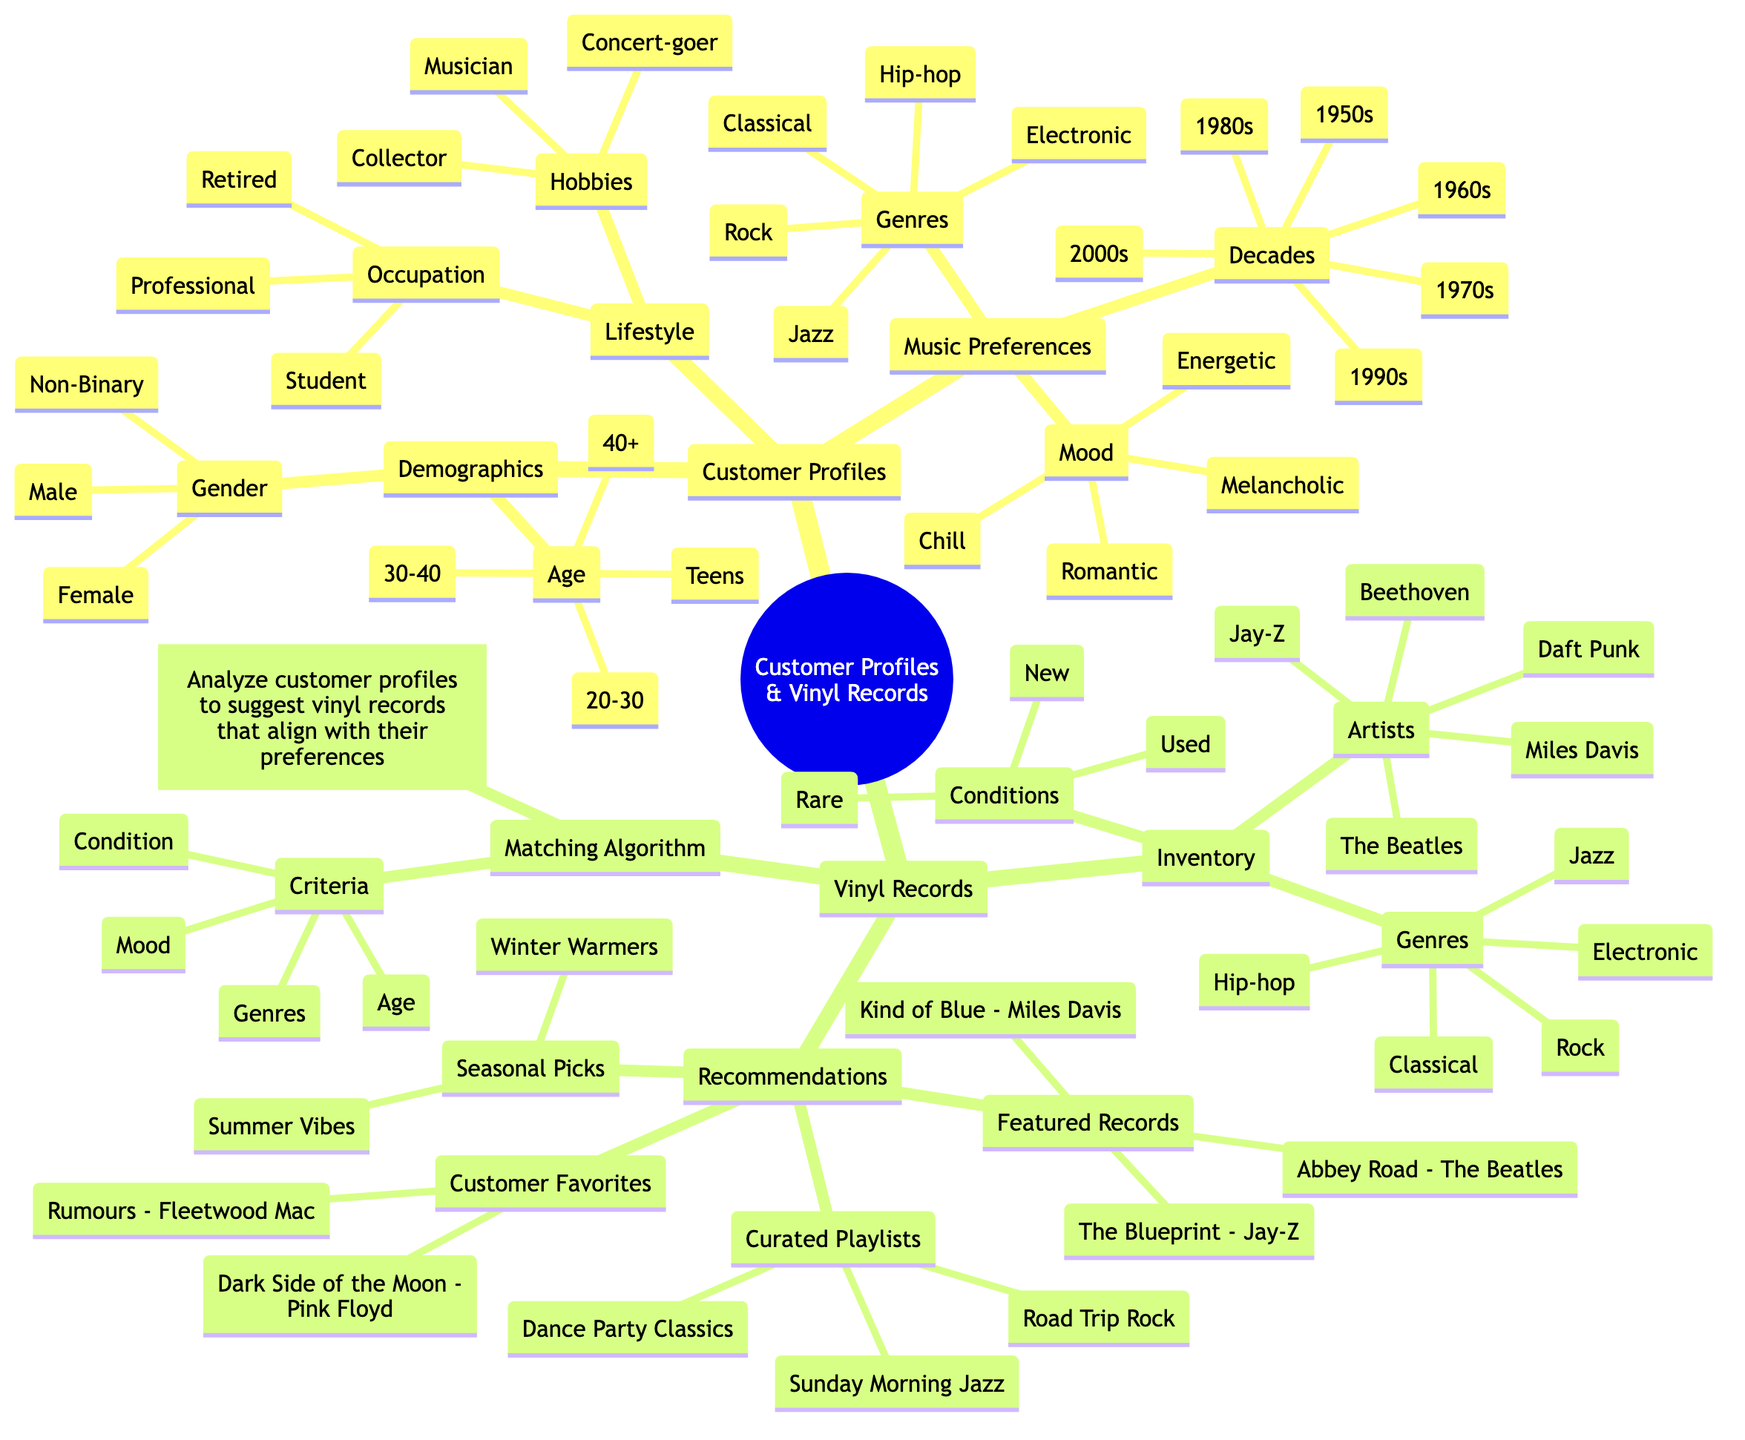What age groups are included in the customer profiles? The customer profiles section mentions age groups as part of the demographics. The specific age groups listed are "Teens," "20-30," "30-40," and "40+."
Answer: Teens, 20-30, 30-40, 40+ How many music genres are listed under music preferences? Looking at the Music Preferences section, there are two subcategories: Genres and each subcategory lists five specific genres: Rock, Jazz, Hip-hop, Classical, and Electronic. So, the total is five genres.
Answer: 5 What conditions are available for the vinyl records in the inventory? In the Vinyl Records Inventory section, the Conditions listed are "New," "Used," and "Rare." Therefore, there are three conditions.
Answer: New, Used, Rare Which playlist is suggested for a relaxing listening experience? By analyzing the Recommendations under Curated Playlists, "Sunday Morning Jazz" is associated with a chill ambiance that fits a relaxing mood.
Answer: Sunday Morning Jazz If a customer prefers Hip-hop music, what is a recommended featured record? In the Vinyl Records Recommendations section, "The Blueprint - Jay-Z" is explicitly categorized as a featured record under the Hip-hop genre, making it a suitable recommendation.
Answer: The Blueprint - Jay-Z How many customer favorite records are listed? In the Customer Favorites subsection, there are two records specifically mentioned. The records listed are "Dark Side of the Moon - Pink Floyd" and "Rumours - Fleetwood Mac." Thus, there are two customer favorites.
Answer: 2 What four criteria does the matching algorithm consider? The Matching Algorithm section lists the following criteria for matching: "Age," "Genres," "Mood," and "Condition." Therefore, those are the four criteria taken into account.
Answer: Age, Genres, Mood, Condition What hobbies do customers have in the lifestyle section? The Lifestyle segment of the Customer Profiles includes three hobbies: "Concert-goer," "Musician," and "Collector." Therefore, those hobbies are what the customers engage in.
Answer: Concert-goer, Musician, Collector Which decades are represented in the music preferences? The Music Preferences section includes the following decades: "1950s," "1960s," "1970s," "1980s," "1990s," and "2000s." In total, six decades are represented, indicating a broad range of musical eras.
Answer: 1950s, 1960s, 1970s, 1980s, 1990s, 2000s 